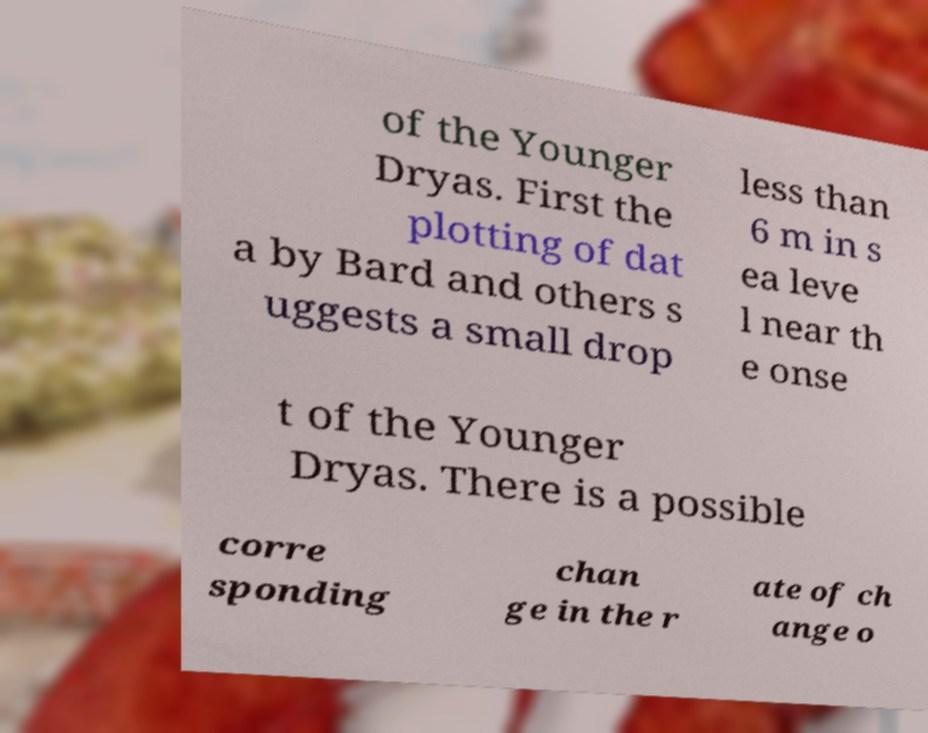Please read and relay the text visible in this image. What does it say? of the Younger Dryas. First the plotting of dat a by Bard and others s uggests a small drop less than 6 m in s ea leve l near th e onse t of the Younger Dryas. There is a possible corre sponding chan ge in the r ate of ch ange o 